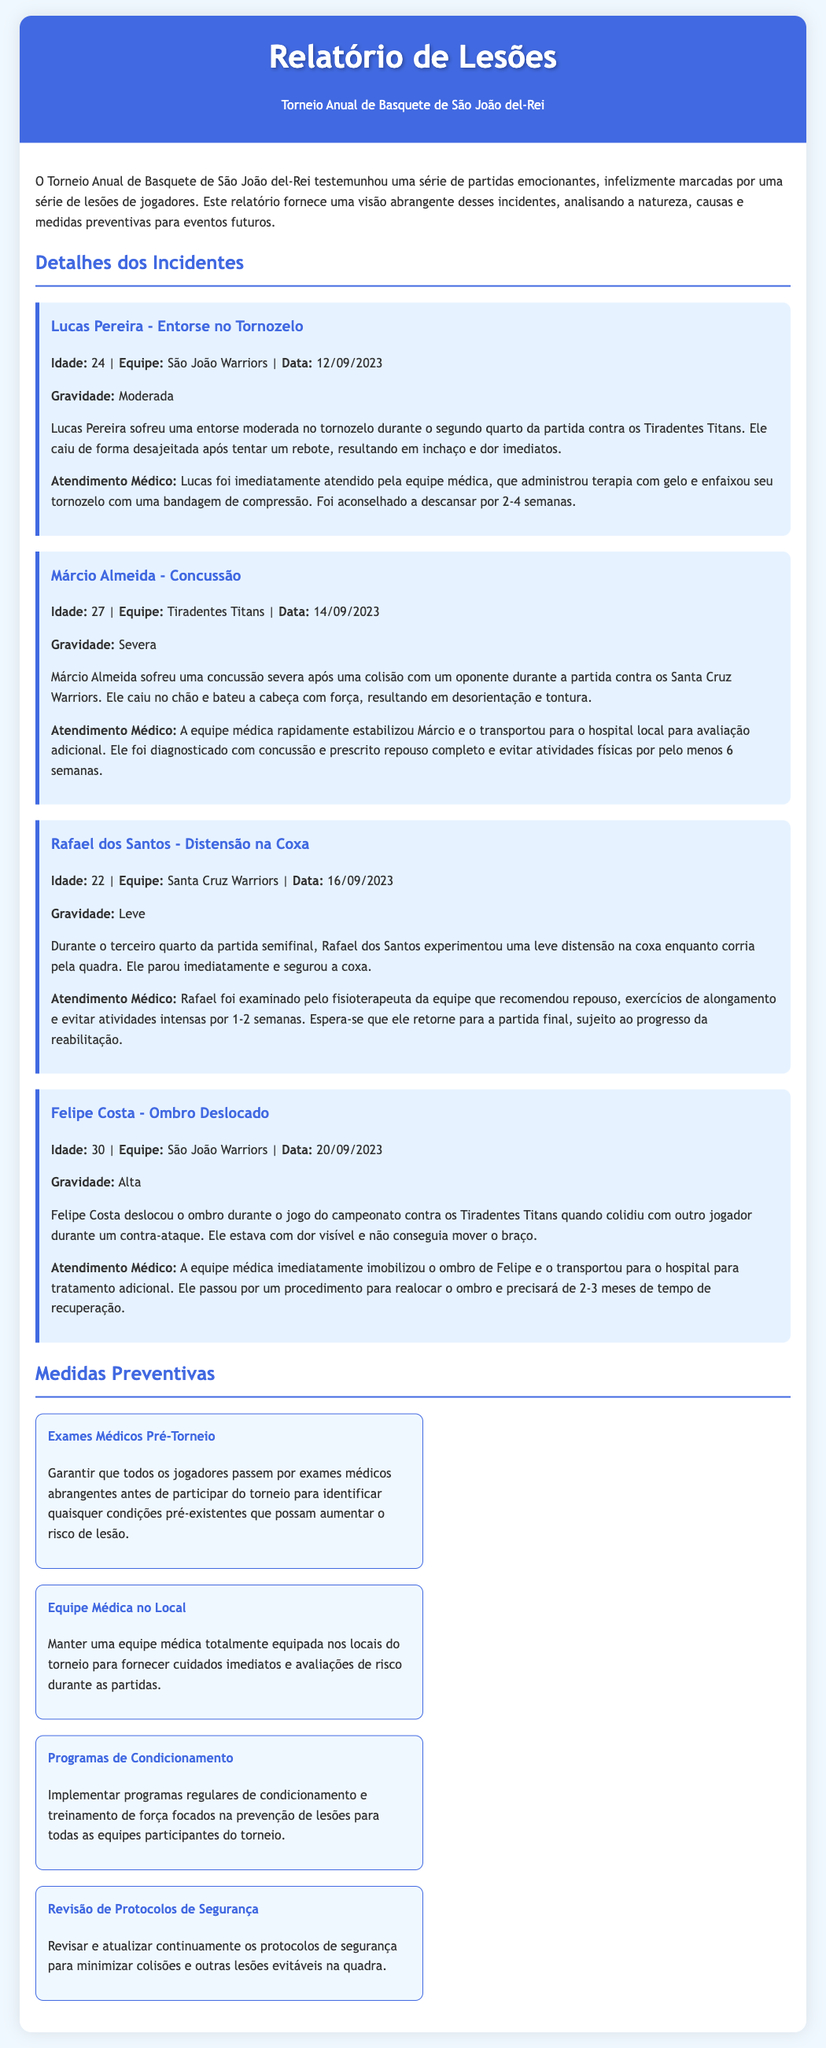What is the title of the report? The title of the report is found in the header of the document, indicating its main subject.
Answer: Relatório de Lesões How many players were mentioned in the incident details? Each player who suffered an injury is included in the "Detalhes dos Incidentes" section, and the count gives the total number of incidents listed.
Answer: 4 What type of injury did Márcio Almeida suffer? The report specifies the nature of Márcio Almeida's injury under his incident details, which categorizes the type of injury he experienced.
Answer: Concussão What was the recovery time advised for Felipe Costa? The recovery recommendations for Felipe Costa are stated clearly in the incident detailing his injury, specifying the duration needed for healing.
Answer: 2-3 meses What preventive measure involves pre-tournament checks? The document presents several measures aimed at reducing injuries, one of which emphasizes the importance of checks prior to the tournament.
Answer: Exames Médicos Pré-Torneio Which team did Rafael dos Santos play for? The team affiliation of each player is provided alongside their injuries in the report, indicating their respective teams.
Answer: Santa Cruz Warriors How severe was Lucas Pereira's injury? The severity of injuries for each player is listed in their respective incident descriptions, providing insight into the extent of each injury.
Answer: Moderada On what date did the injury to Felipe Costa occur? Specific incident dates for each reported injury can be found in their individual sections detailing when they took place during the tournament.
Answer: 20/09/2023 